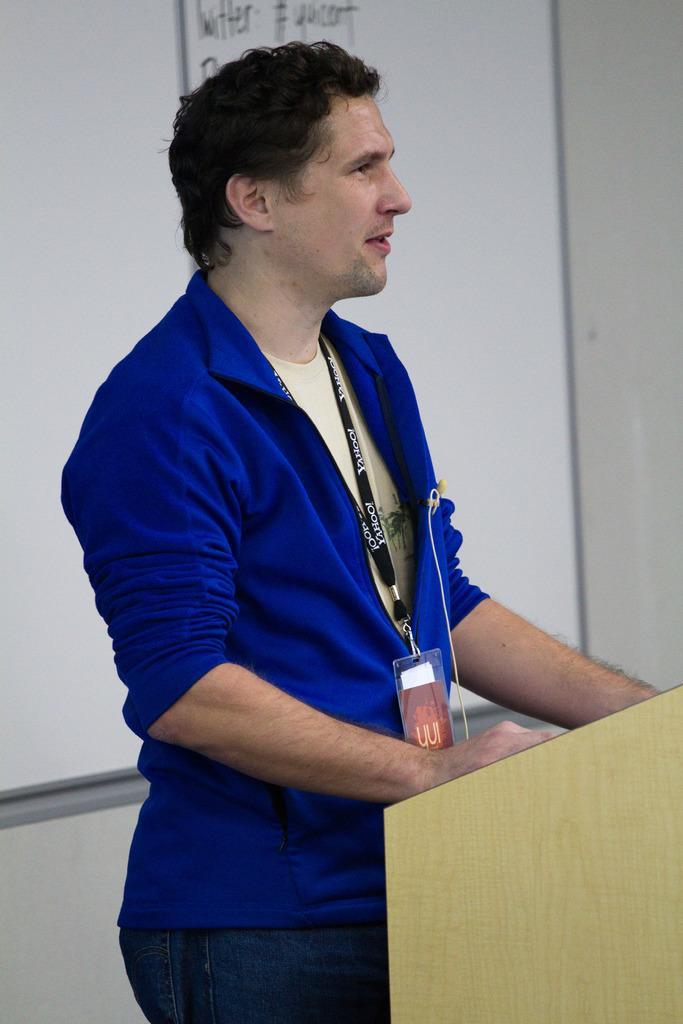In one or two sentences, can you explain what this image depicts? In this image we can see a person wearing blue jacket and identity card is standing near the podium. In the background, we can see the white color board to the wall on which we can see some text written. 